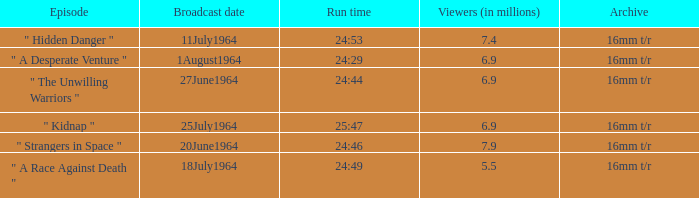What episode aired on 11july1964? " Hidden Danger ". 